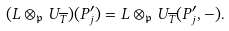<formula> <loc_0><loc_0><loc_500><loc_500>( L \otimes _ { \mathfrak { p } } U _ { \overline { T } } ) ( P _ { j } ^ { \prime } ) = L \otimes _ { \mathfrak { p } } U _ { \overline { T } } ( P _ { j } ^ { \prime } , - ) .</formula> 